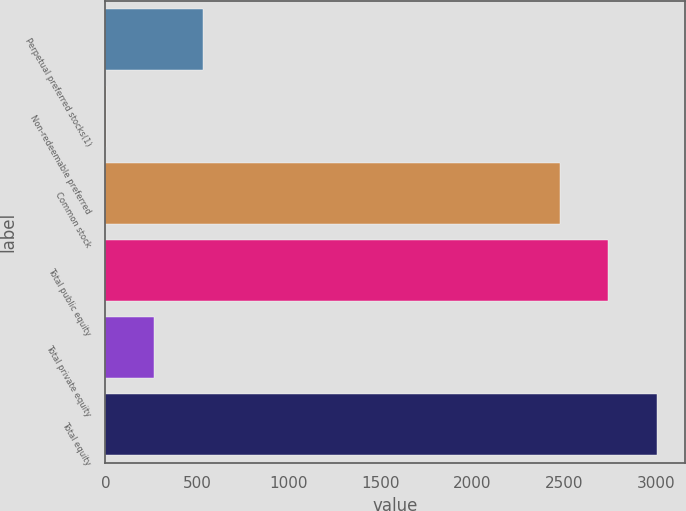Convert chart to OTSL. <chart><loc_0><loc_0><loc_500><loc_500><bar_chart><fcel>Perpetual preferred stocks(1)<fcel>Non-redeemable preferred<fcel>Common stock<fcel>Total public equity<fcel>Total private equity<fcel>Total equity<nl><fcel>530.2<fcel>1<fcel>2476<fcel>2740.6<fcel>265.6<fcel>3005.2<nl></chart> 